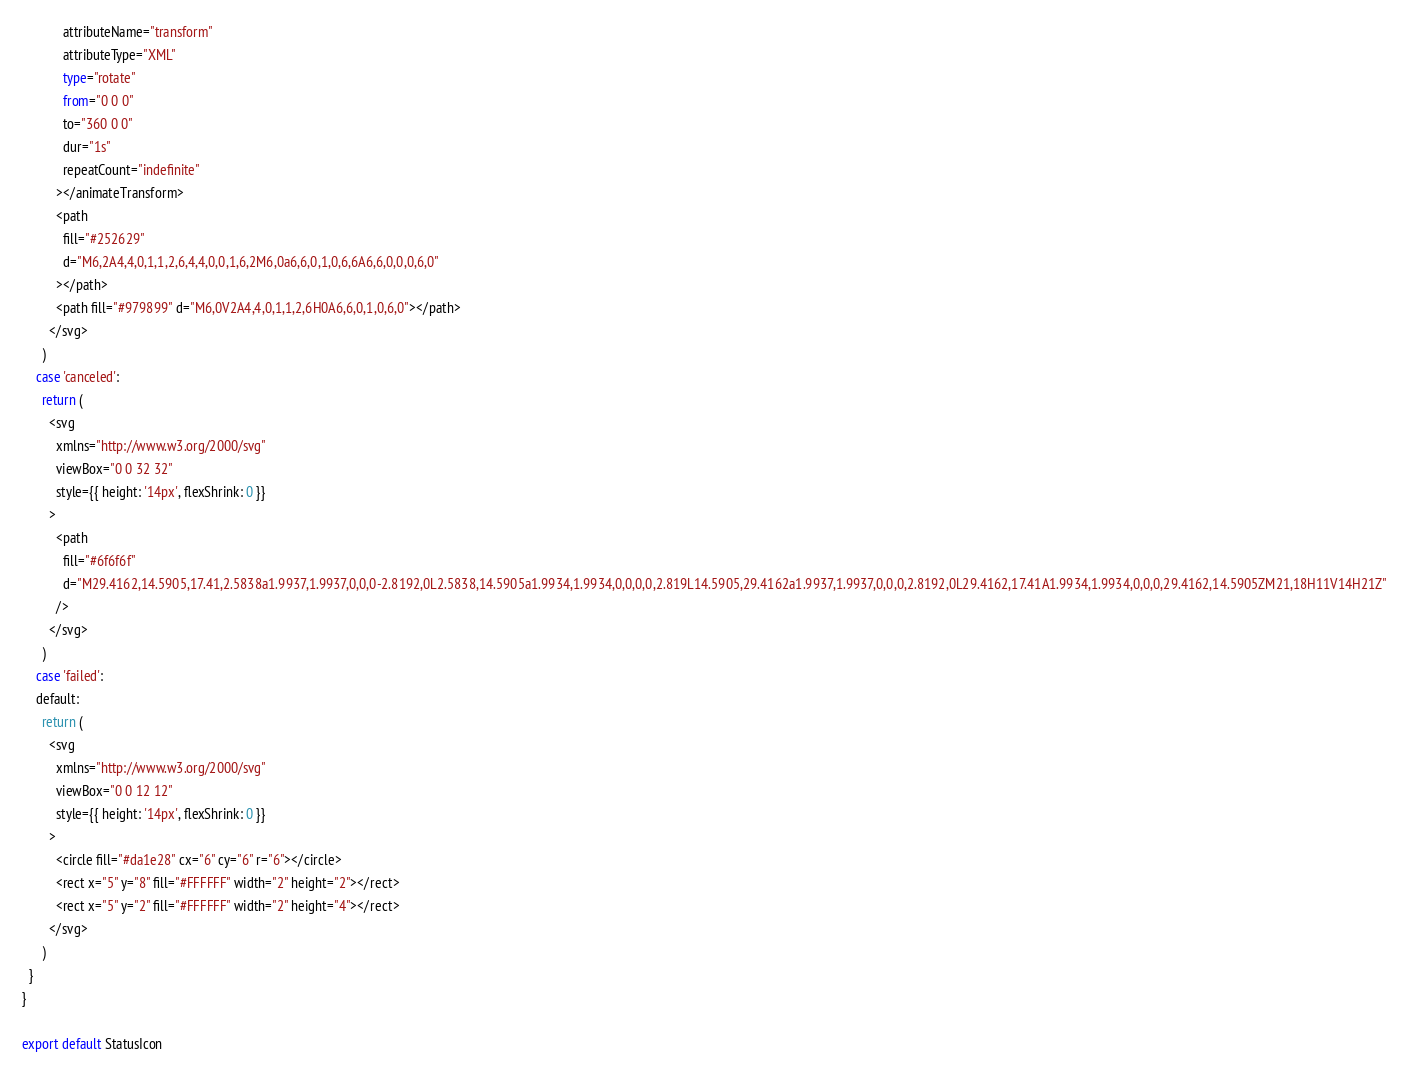<code> <loc_0><loc_0><loc_500><loc_500><_TypeScript_>            attributeName="transform"
            attributeType="XML"
            type="rotate"
            from="0 0 0"
            to="360 0 0"
            dur="1s"
            repeatCount="indefinite"
          ></animateTransform>
          <path
            fill="#252629"
            d="M6,2A4,4,0,1,1,2,6,4,4,0,0,1,6,2M6,0a6,6,0,1,0,6,6A6,6,0,0,0,6,0"
          ></path>
          <path fill="#979899" d="M6,0V2A4,4,0,1,1,2,6H0A6,6,0,1,0,6,0"></path>
        </svg>
      )
    case 'canceled':
      return (
        <svg
          xmlns="http://www.w3.org/2000/svg"
          viewBox="0 0 32 32"
          style={{ height: '14px', flexShrink: 0 }}
        >
          <path
            fill="#6f6f6f"
            d="M29.4162,14.5905,17.41,2.5838a1.9937,1.9937,0,0,0-2.8192,0L2.5838,14.5905a1.9934,1.9934,0,0,0,0,2.819L14.5905,29.4162a1.9937,1.9937,0,0,0,2.8192,0L29.4162,17.41A1.9934,1.9934,0,0,0,29.4162,14.5905ZM21,18H11V14H21Z"
          />
        </svg>
      )
    case 'failed':
    default:
      return (
        <svg
          xmlns="http://www.w3.org/2000/svg"
          viewBox="0 0 12 12"
          style={{ height: '14px', flexShrink: 0 }}
        >
          <circle fill="#da1e28" cx="6" cy="6" r="6"></circle>
          <rect x="5" y="8" fill="#FFFFFF" width="2" height="2"></rect>
          <rect x="5" y="2" fill="#FFFFFF" width="2" height="4"></rect>
        </svg>
      )
  }
}

export default StatusIcon
</code> 